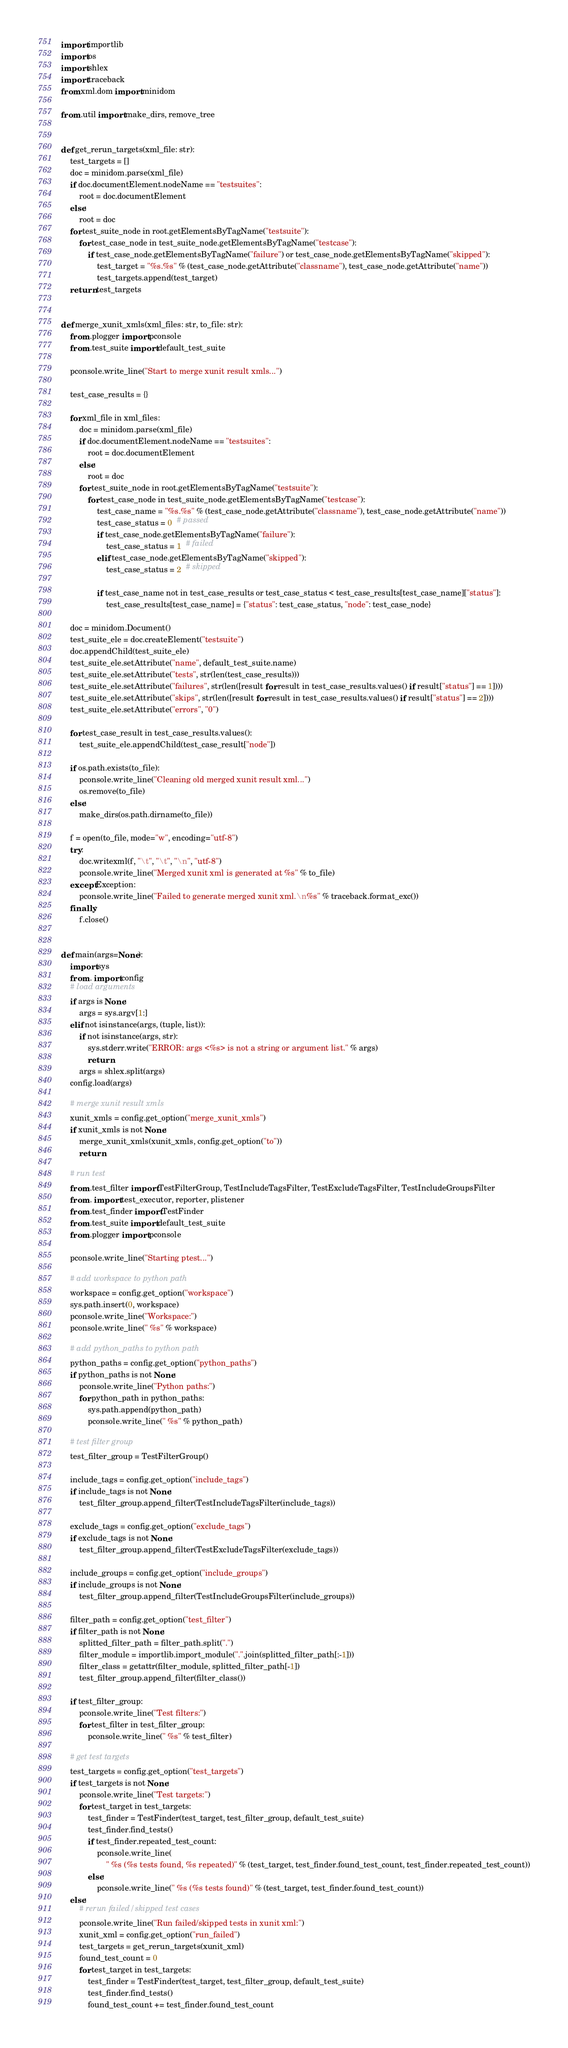<code> <loc_0><loc_0><loc_500><loc_500><_Python_>import importlib
import os
import shlex
import traceback
from xml.dom import minidom

from .util import make_dirs, remove_tree


def get_rerun_targets(xml_file: str):
    test_targets = []
    doc = minidom.parse(xml_file)
    if doc.documentElement.nodeName == "testsuites":
        root = doc.documentElement
    else:
        root = doc
    for test_suite_node in root.getElementsByTagName("testsuite"):
        for test_case_node in test_suite_node.getElementsByTagName("testcase"):
            if test_case_node.getElementsByTagName("failure") or test_case_node.getElementsByTagName("skipped"):
                test_target = "%s.%s" % (test_case_node.getAttribute("classname"), test_case_node.getAttribute("name"))
                test_targets.append(test_target)
    return test_targets


def merge_xunit_xmls(xml_files: str, to_file: str):
    from .plogger import pconsole
    from .test_suite import default_test_suite

    pconsole.write_line("Start to merge xunit result xmls...")

    test_case_results = {}

    for xml_file in xml_files:
        doc = minidom.parse(xml_file)
        if doc.documentElement.nodeName == "testsuites":
            root = doc.documentElement
        else:
            root = doc
        for test_suite_node in root.getElementsByTagName("testsuite"):
            for test_case_node in test_suite_node.getElementsByTagName("testcase"):
                test_case_name = "%s.%s" % (test_case_node.getAttribute("classname"), test_case_node.getAttribute("name"))
                test_case_status = 0  # passed
                if test_case_node.getElementsByTagName("failure"):
                    test_case_status = 1  # failed
                elif test_case_node.getElementsByTagName("skipped"):
                    test_case_status = 2  # skipped

                if test_case_name not in test_case_results or test_case_status < test_case_results[test_case_name]["status"]:
                    test_case_results[test_case_name] = {"status": test_case_status, "node": test_case_node}

    doc = minidom.Document()
    test_suite_ele = doc.createElement("testsuite")
    doc.appendChild(test_suite_ele)
    test_suite_ele.setAttribute("name", default_test_suite.name)
    test_suite_ele.setAttribute("tests", str(len(test_case_results)))
    test_suite_ele.setAttribute("failures", str(len([result for result in test_case_results.values() if result["status"] == 1])))
    test_suite_ele.setAttribute("skips", str(len([result for result in test_case_results.values() if result["status"] == 2])))
    test_suite_ele.setAttribute("errors", "0")

    for test_case_result in test_case_results.values():
        test_suite_ele.appendChild(test_case_result["node"])

    if os.path.exists(to_file):
        pconsole.write_line("Cleaning old merged xunit result xml...")
        os.remove(to_file)
    else:
        make_dirs(os.path.dirname(to_file))

    f = open(to_file, mode="w", encoding="utf-8")
    try:
        doc.writexml(f, "\t", "\t", "\n", "utf-8")
        pconsole.write_line("Merged xunit xml is generated at %s" % to_file)
    except Exception:
        pconsole.write_line("Failed to generate merged xunit xml.\n%s" % traceback.format_exc())
    finally:
        f.close()


def main(args=None):
    import sys
    from . import config
    # load arguments
    if args is None:
        args = sys.argv[1:]
    elif not isinstance(args, (tuple, list)):
        if not isinstance(args, str):
            sys.stderr.write("ERROR: args <%s> is not a string or argument list." % args)
            return
        args = shlex.split(args)
    config.load(args)

    # merge xunit result xmls
    xunit_xmls = config.get_option("merge_xunit_xmls")
    if xunit_xmls is not None:
        merge_xunit_xmls(xunit_xmls, config.get_option("to"))
        return

    # run test
    from .test_filter import TestFilterGroup, TestIncludeTagsFilter, TestExcludeTagsFilter, TestIncludeGroupsFilter
    from . import test_executor, reporter, plistener
    from .test_finder import TestFinder
    from .test_suite import default_test_suite
    from .plogger import pconsole

    pconsole.write_line("Starting ptest...")

    # add workspace to python path
    workspace = config.get_option("workspace")
    sys.path.insert(0, workspace)
    pconsole.write_line("Workspace:")
    pconsole.write_line(" %s" % workspace)

    # add python_paths to python path
    python_paths = config.get_option("python_paths")
    if python_paths is not None:
        pconsole.write_line("Python paths:")
        for python_path in python_paths:
            sys.path.append(python_path)
            pconsole.write_line(" %s" % python_path)

    # test filter group
    test_filter_group = TestFilterGroup()

    include_tags = config.get_option("include_tags")
    if include_tags is not None:
        test_filter_group.append_filter(TestIncludeTagsFilter(include_tags))

    exclude_tags = config.get_option("exclude_tags")
    if exclude_tags is not None:
        test_filter_group.append_filter(TestExcludeTagsFilter(exclude_tags))

    include_groups = config.get_option("include_groups")
    if include_groups is not None:
        test_filter_group.append_filter(TestIncludeGroupsFilter(include_groups))

    filter_path = config.get_option("test_filter")
    if filter_path is not None:
        splitted_filter_path = filter_path.split(".")
        filter_module = importlib.import_module(".".join(splitted_filter_path[:-1]))
        filter_class = getattr(filter_module, splitted_filter_path[-1])
        test_filter_group.append_filter(filter_class())

    if test_filter_group:
        pconsole.write_line("Test filters:")
        for test_filter in test_filter_group:
            pconsole.write_line(" %s" % test_filter)

    # get test targets
    test_targets = config.get_option("test_targets")
    if test_targets is not None:
        pconsole.write_line("Test targets:")
        for test_target in test_targets:
            test_finder = TestFinder(test_target, test_filter_group, default_test_suite)
            test_finder.find_tests()
            if test_finder.repeated_test_count:
                pconsole.write_line(
                    " %s (%s tests found, %s repeated)" % (test_target, test_finder.found_test_count, test_finder.repeated_test_count))
            else:
                pconsole.write_line(" %s (%s tests found)" % (test_target, test_finder.found_test_count))
    else:
        # rerun failed/skipped test cases
        pconsole.write_line("Run failed/skipped tests in xunit xml:")
        xunit_xml = config.get_option("run_failed")
        test_targets = get_rerun_targets(xunit_xml)
        found_test_count = 0
        for test_target in test_targets:
            test_finder = TestFinder(test_target, test_filter_group, default_test_suite)
            test_finder.find_tests()
            found_test_count += test_finder.found_test_count</code> 